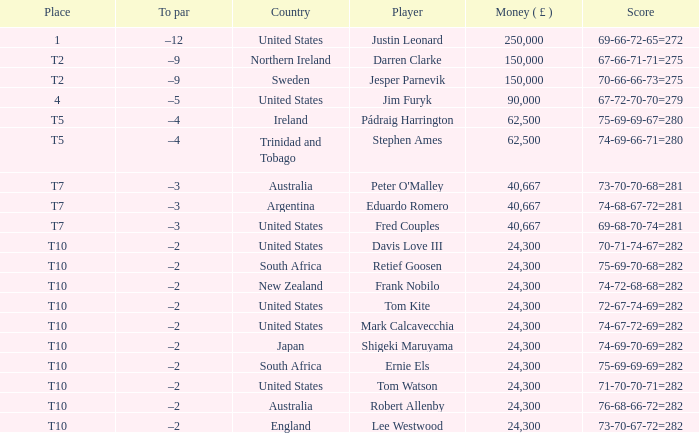What is the total sum of money won by frank nobilo? 1.0. Would you be able to parse every entry in this table? {'header': ['Place', 'To par', 'Country', 'Player', 'Money ( £ )', 'Score'], 'rows': [['1', '–12', 'United States', 'Justin Leonard', '250,000', '69-66-72-65=272'], ['T2', '–9', 'Northern Ireland', 'Darren Clarke', '150,000', '67-66-71-71=275'], ['T2', '–9', 'Sweden', 'Jesper Parnevik', '150,000', '70-66-66-73=275'], ['4', '–5', 'United States', 'Jim Furyk', '90,000', '67-72-70-70=279'], ['T5', '–4', 'Ireland', 'Pádraig Harrington', '62,500', '75-69-69-67=280'], ['T5', '–4', 'Trinidad and Tobago', 'Stephen Ames', '62,500', '74-69-66-71=280'], ['T7', '–3', 'Australia', "Peter O'Malley", '40,667', '73-70-70-68=281'], ['T7', '–3', 'Argentina', 'Eduardo Romero', '40,667', '74-68-67-72=281'], ['T7', '–3', 'United States', 'Fred Couples', '40,667', '69-68-70-74=281'], ['T10', '–2', 'United States', 'Davis Love III', '24,300', '70-71-74-67=282'], ['T10', '–2', 'South Africa', 'Retief Goosen', '24,300', '75-69-70-68=282'], ['T10', '–2', 'New Zealand', 'Frank Nobilo', '24,300', '74-72-68-68=282'], ['T10', '–2', 'United States', 'Tom Kite', '24,300', '72-67-74-69=282'], ['T10', '–2', 'United States', 'Mark Calcavecchia', '24,300', '74-67-72-69=282'], ['T10', '–2', 'Japan', 'Shigeki Maruyama', '24,300', '74-69-70-69=282'], ['T10', '–2', 'South Africa', 'Ernie Els', '24,300', '75-69-69-69=282'], ['T10', '–2', 'United States', 'Tom Watson', '24,300', '71-70-70-71=282'], ['T10', '–2', 'Australia', 'Robert Allenby', '24,300', '76-68-66-72=282'], ['T10', '–2', 'England', 'Lee Westwood', '24,300', '73-70-67-72=282']]} 